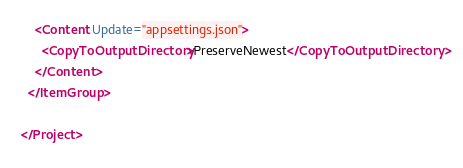Convert code to text. <code><loc_0><loc_0><loc_500><loc_500><_XML_>    <Content Update="appsettings.json">
      <CopyToOutputDirectory>PreserveNewest</CopyToOutputDirectory>
    </Content>
  </ItemGroup>

</Project>
</code> 